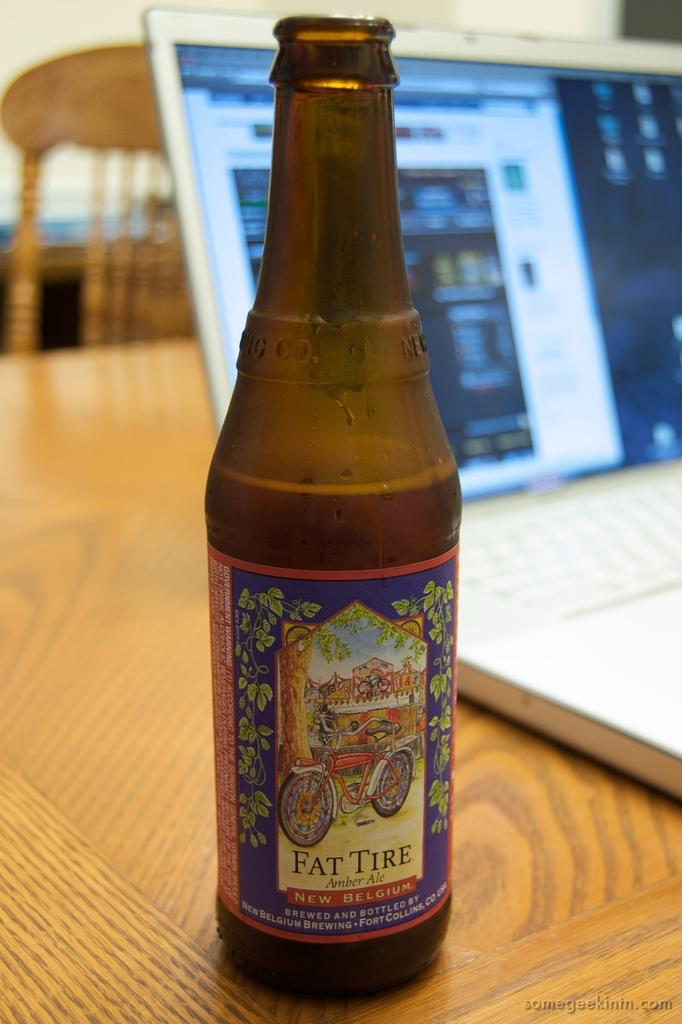<image>
Write a terse but informative summary of the picture. A bottle of Fat Tire beer on a desk near a laptop. 